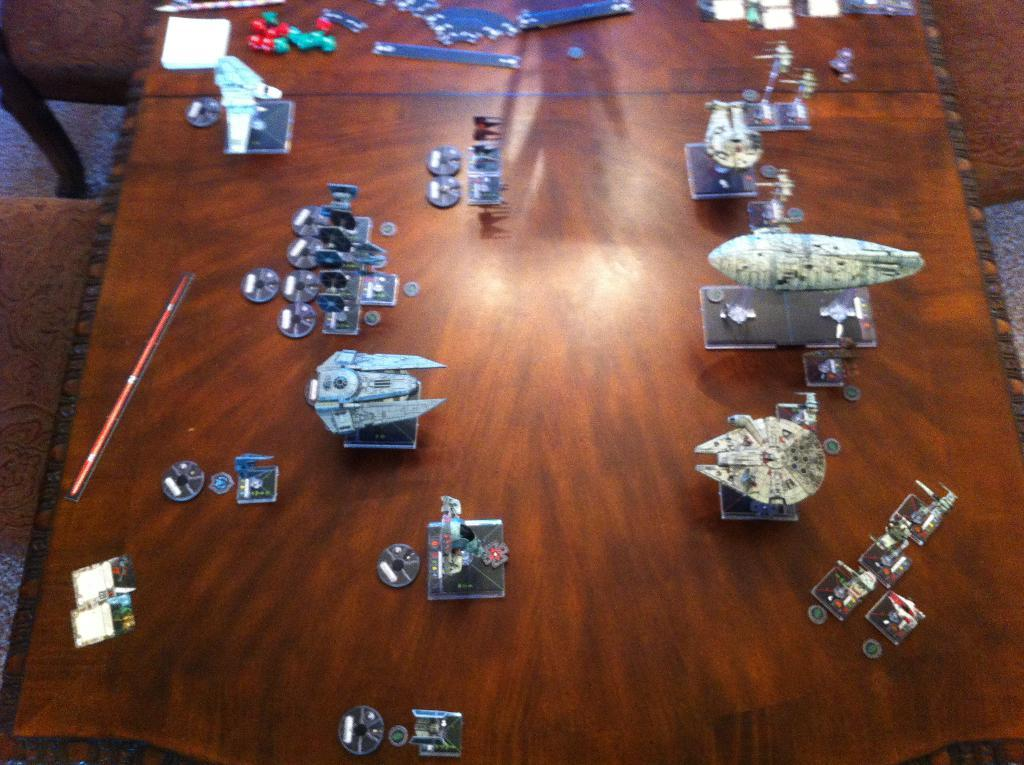What is on the table in the image? There are toys and other objects on a table in the image. What can be seen on the floor on the left side of the image? There are chairs on the floor on the left side of the image. What type of action is being performed by the metal sponge in the image? There is no metal sponge present in the image, so no action can be attributed to it. 